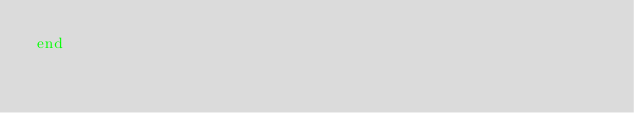<code> <loc_0><loc_0><loc_500><loc_500><_Ruby_>end
</code> 